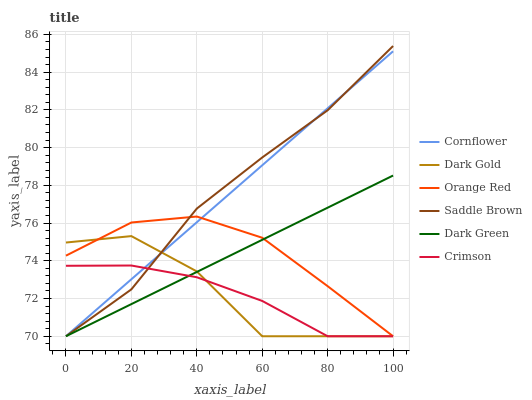Does Crimson have the minimum area under the curve?
Answer yes or no. Yes. Does Saddle Brown have the maximum area under the curve?
Answer yes or no. Yes. Does Dark Gold have the minimum area under the curve?
Answer yes or no. No. Does Dark Gold have the maximum area under the curve?
Answer yes or no. No. Is Cornflower the smoothest?
Answer yes or no. Yes. Is Dark Gold the roughest?
Answer yes or no. Yes. Is Orange Red the smoothest?
Answer yes or no. No. Is Orange Red the roughest?
Answer yes or no. No. Does Cornflower have the lowest value?
Answer yes or no. Yes. Does Saddle Brown have the highest value?
Answer yes or no. Yes. Does Dark Gold have the highest value?
Answer yes or no. No. Does Dark Green intersect Dark Gold?
Answer yes or no. Yes. Is Dark Green less than Dark Gold?
Answer yes or no. No. Is Dark Green greater than Dark Gold?
Answer yes or no. No. 